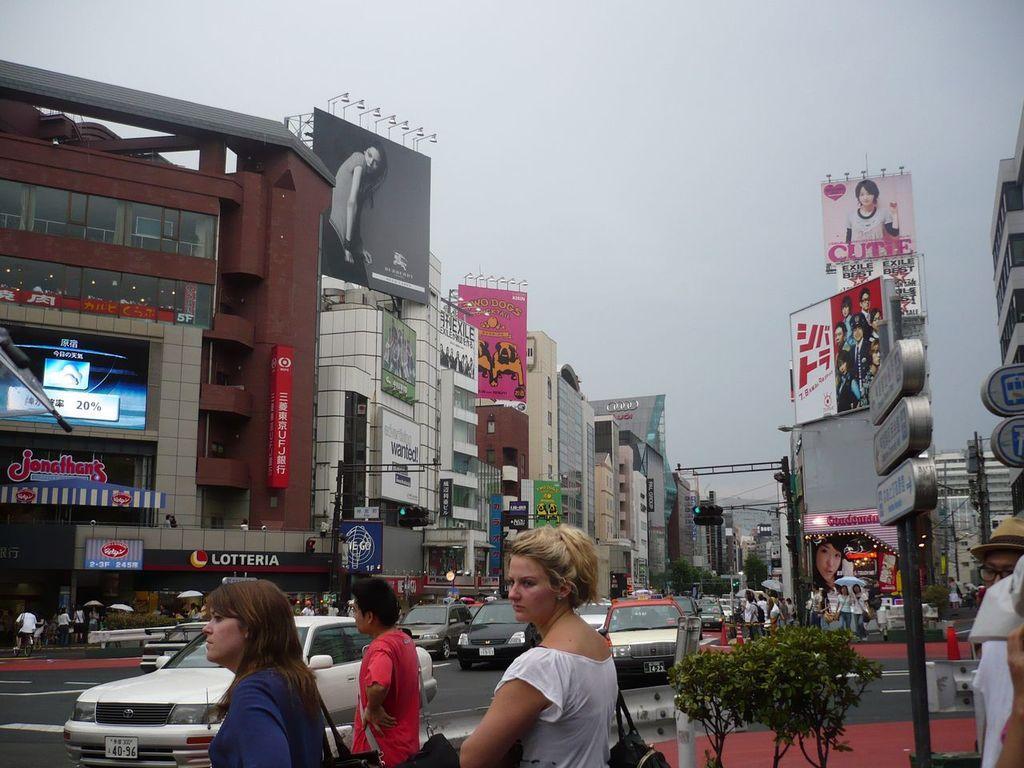Can you describe this image briefly? In this picture I can see there are three people standing at the bottom of the image and there are few other people standing at the right bottom of the image and there are poles with boards. There are few buildings in the backdrop and there are few vehicles moving on the road and the sky is clear. 